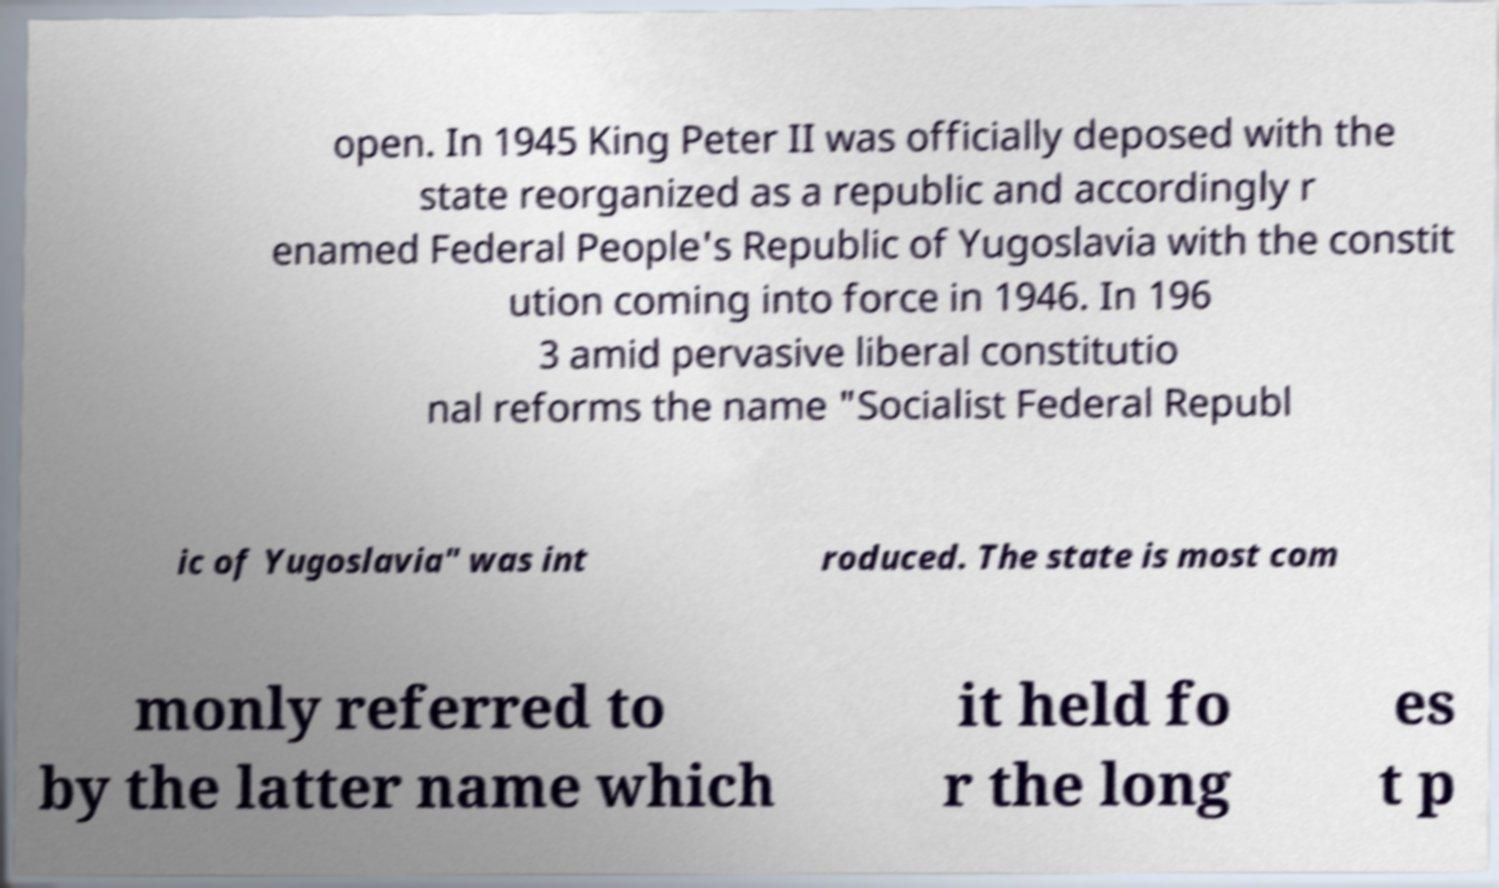Can you accurately transcribe the text from the provided image for me? open. In 1945 King Peter II was officially deposed with the state reorganized as a republic and accordingly r enamed Federal People's Republic of Yugoslavia with the constit ution coming into force in 1946. In 196 3 amid pervasive liberal constitutio nal reforms the name "Socialist Federal Republ ic of Yugoslavia" was int roduced. The state is most com monly referred to by the latter name which it held fo r the long es t p 